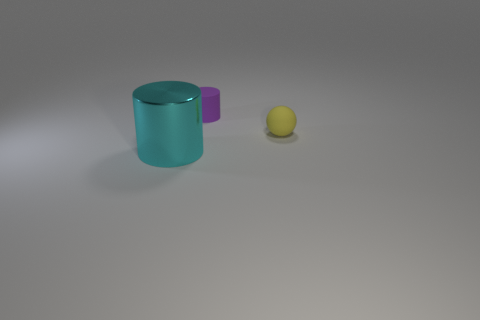Add 3 big gray rubber cubes. How many objects exist? 6 Subtract 0 green blocks. How many objects are left? 3 Subtract all balls. How many objects are left? 2 Subtract all purple cylinders. Subtract all large cyan things. How many objects are left? 1 Add 2 yellow rubber things. How many yellow rubber things are left? 3 Add 3 yellow matte spheres. How many yellow matte spheres exist? 4 